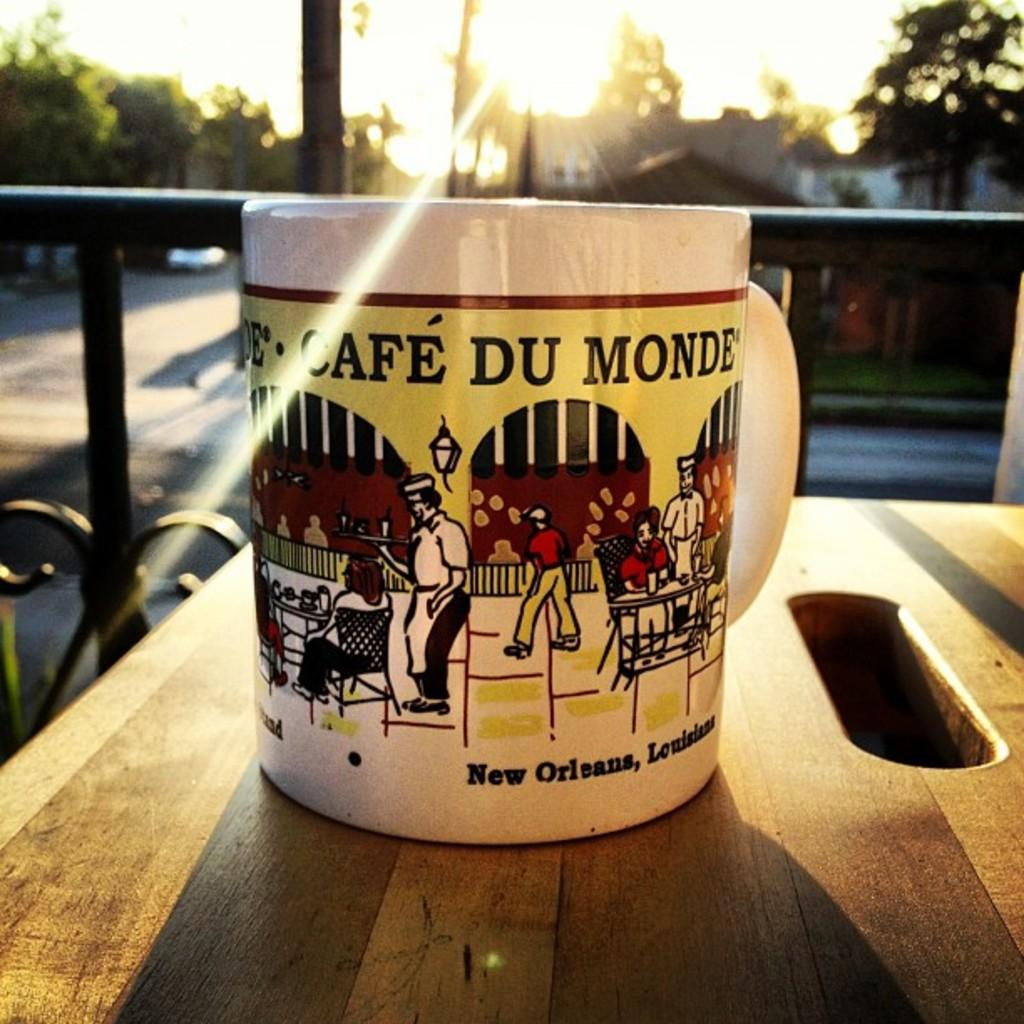<image>
Provide a brief description of the given image. A mug with a scene from.Cafe Du Monde in New Orleans on the front. 